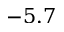Convert formula to latex. <formula><loc_0><loc_0><loc_500><loc_500>- 5 . 7</formula> 